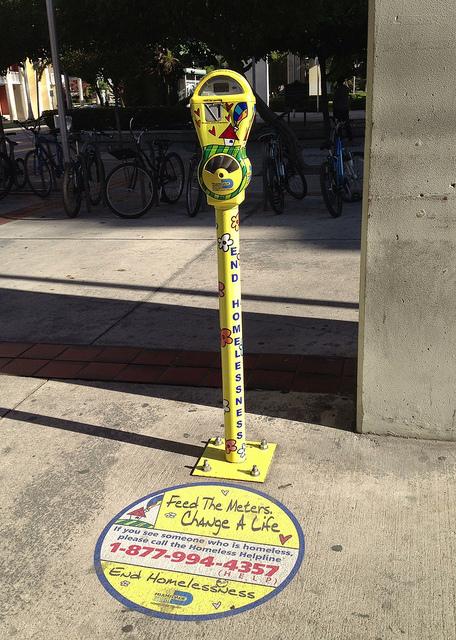Is it sunny?
Quick response, please. Yes. What color is the parking meter?
Be succinct. Yellow. What is the phone number on the ground?
Short answer required. 1-877-994-4357. 